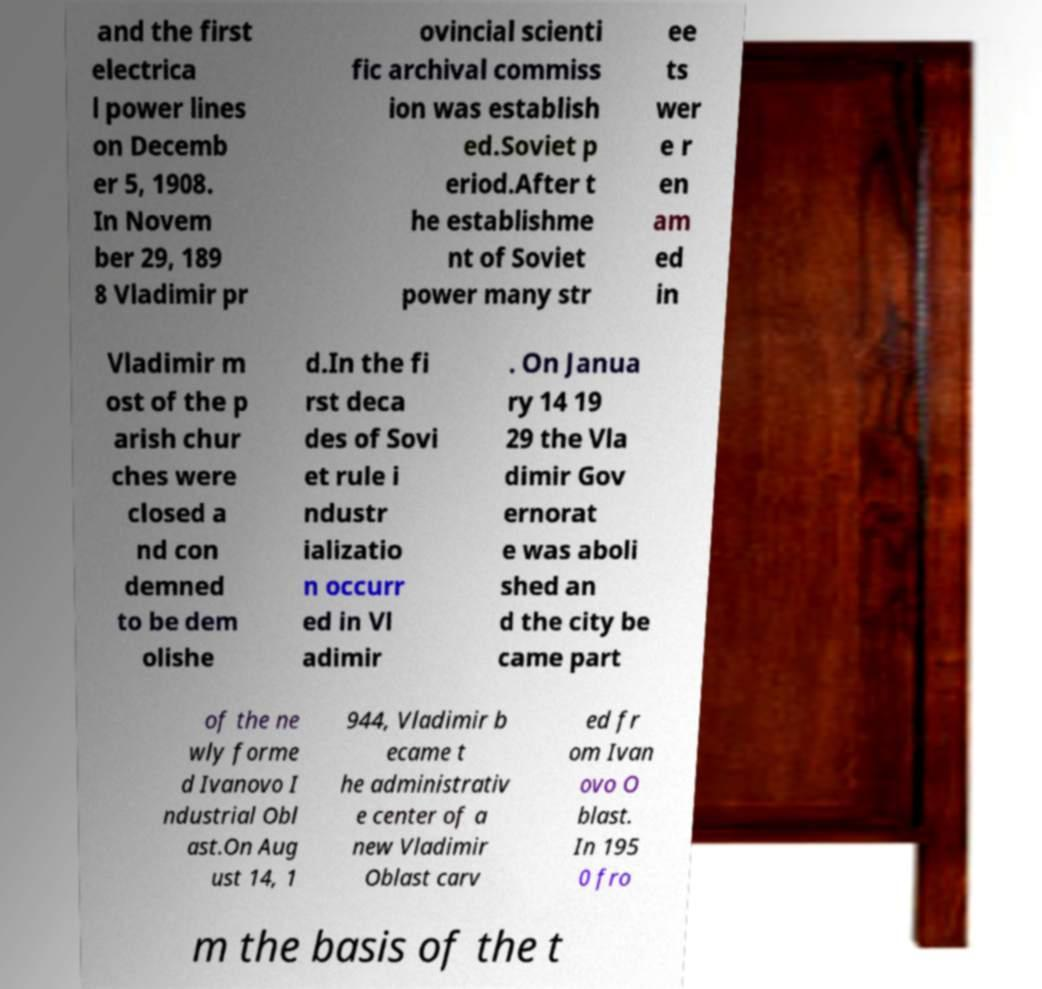Can you accurately transcribe the text from the provided image for me? and the first electrica l power lines on Decemb er 5, 1908. In Novem ber 29, 189 8 Vladimir pr ovincial scienti fic archival commiss ion was establish ed.Soviet p eriod.After t he establishme nt of Soviet power many str ee ts wer e r en am ed in Vladimir m ost of the p arish chur ches were closed a nd con demned to be dem olishe d.In the fi rst deca des of Sovi et rule i ndustr ializatio n occurr ed in Vl adimir . On Janua ry 14 19 29 the Vla dimir Gov ernorat e was aboli shed an d the city be came part of the ne wly forme d Ivanovo I ndustrial Obl ast.On Aug ust 14, 1 944, Vladimir b ecame t he administrativ e center of a new Vladimir Oblast carv ed fr om Ivan ovo O blast. In 195 0 fro m the basis of the t 